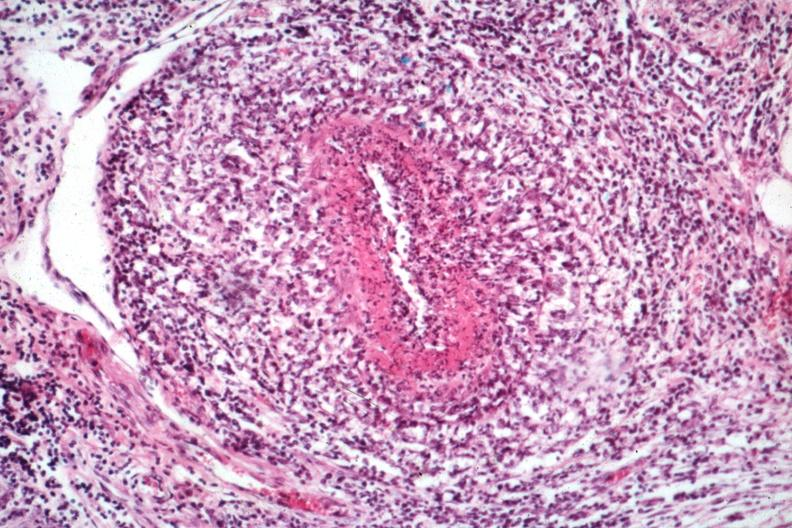what is present?
Answer the question using a single word or phrase. Testicle 